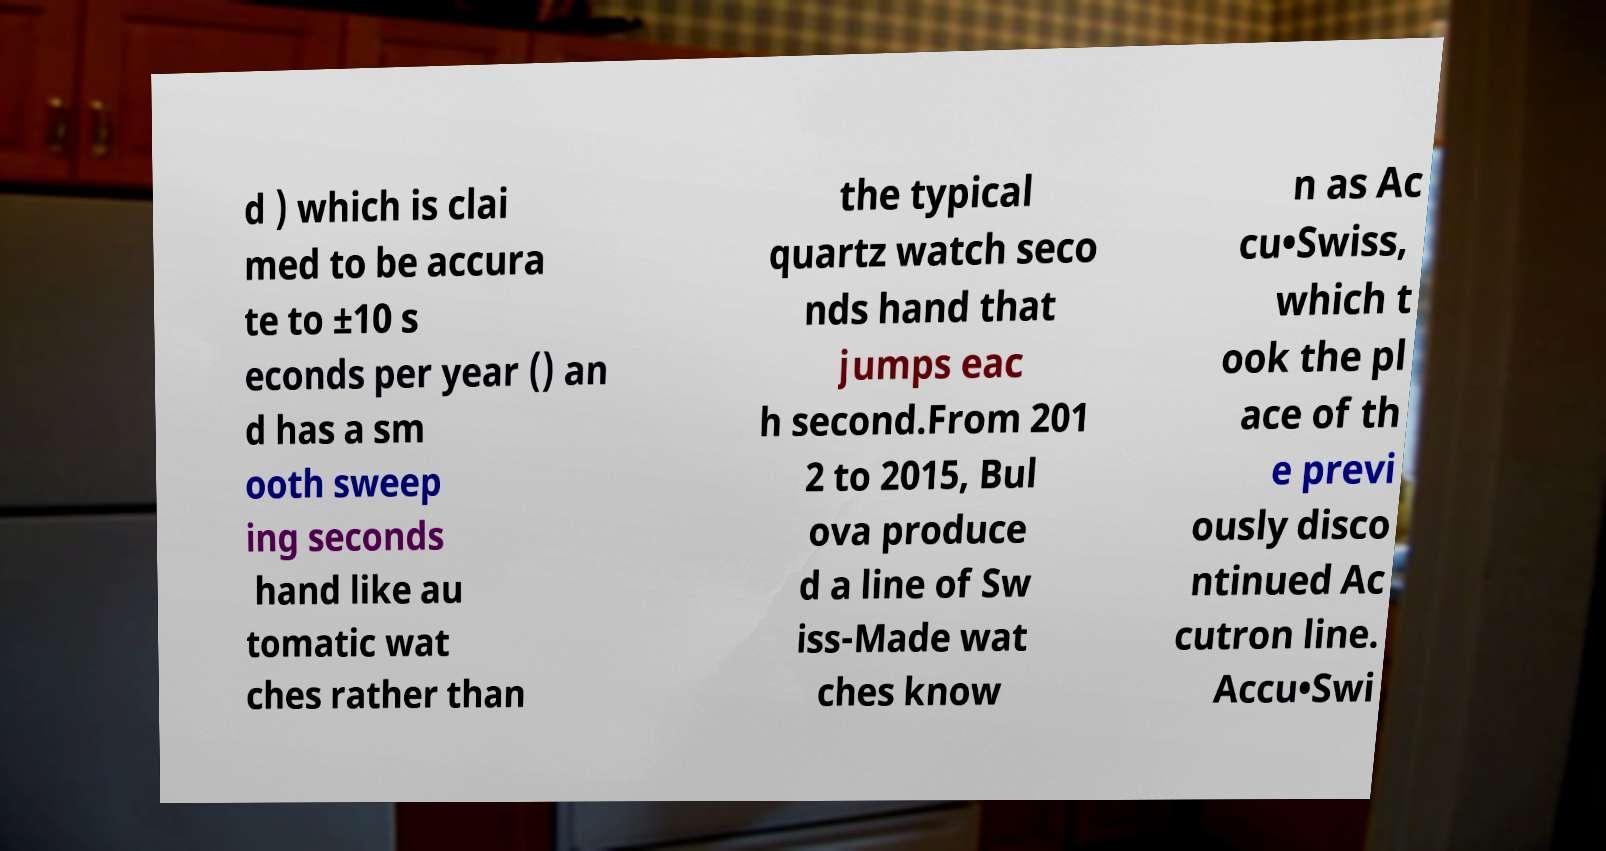Please read and relay the text visible in this image. What does it say? d ) which is clai med to be accura te to ±10 s econds per year () an d has a sm ooth sweep ing seconds hand like au tomatic wat ches rather than the typical quartz watch seco nds hand that jumps eac h second.From 201 2 to 2015, Bul ova produce d a line of Sw iss-Made wat ches know n as Ac cu•Swiss, which t ook the pl ace of th e previ ously disco ntinued Ac cutron line. Accu•Swi 